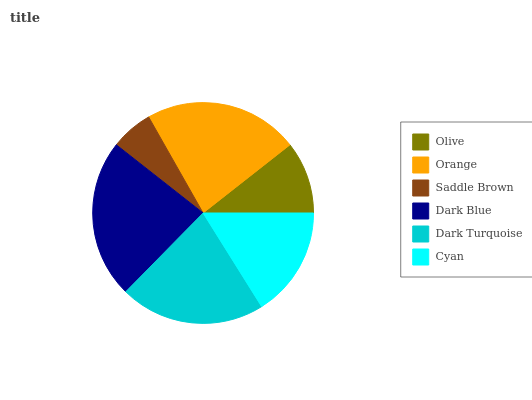Is Saddle Brown the minimum?
Answer yes or no. Yes. Is Dark Blue the maximum?
Answer yes or no. Yes. Is Orange the minimum?
Answer yes or no. No. Is Orange the maximum?
Answer yes or no. No. Is Orange greater than Olive?
Answer yes or no. Yes. Is Olive less than Orange?
Answer yes or no. Yes. Is Olive greater than Orange?
Answer yes or no. No. Is Orange less than Olive?
Answer yes or no. No. Is Dark Turquoise the high median?
Answer yes or no. Yes. Is Cyan the low median?
Answer yes or no. Yes. Is Saddle Brown the high median?
Answer yes or no. No. Is Dark Turquoise the low median?
Answer yes or no. No. 